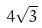Convert formula to latex. <formula><loc_0><loc_0><loc_500><loc_500>4 \sqrt { 3 }</formula> 